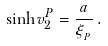Convert formula to latex. <formula><loc_0><loc_0><loc_500><loc_500>\sinh v _ { 2 } ^ { P } = \frac { a } { \xi _ { _ { P } } } \, .</formula> 